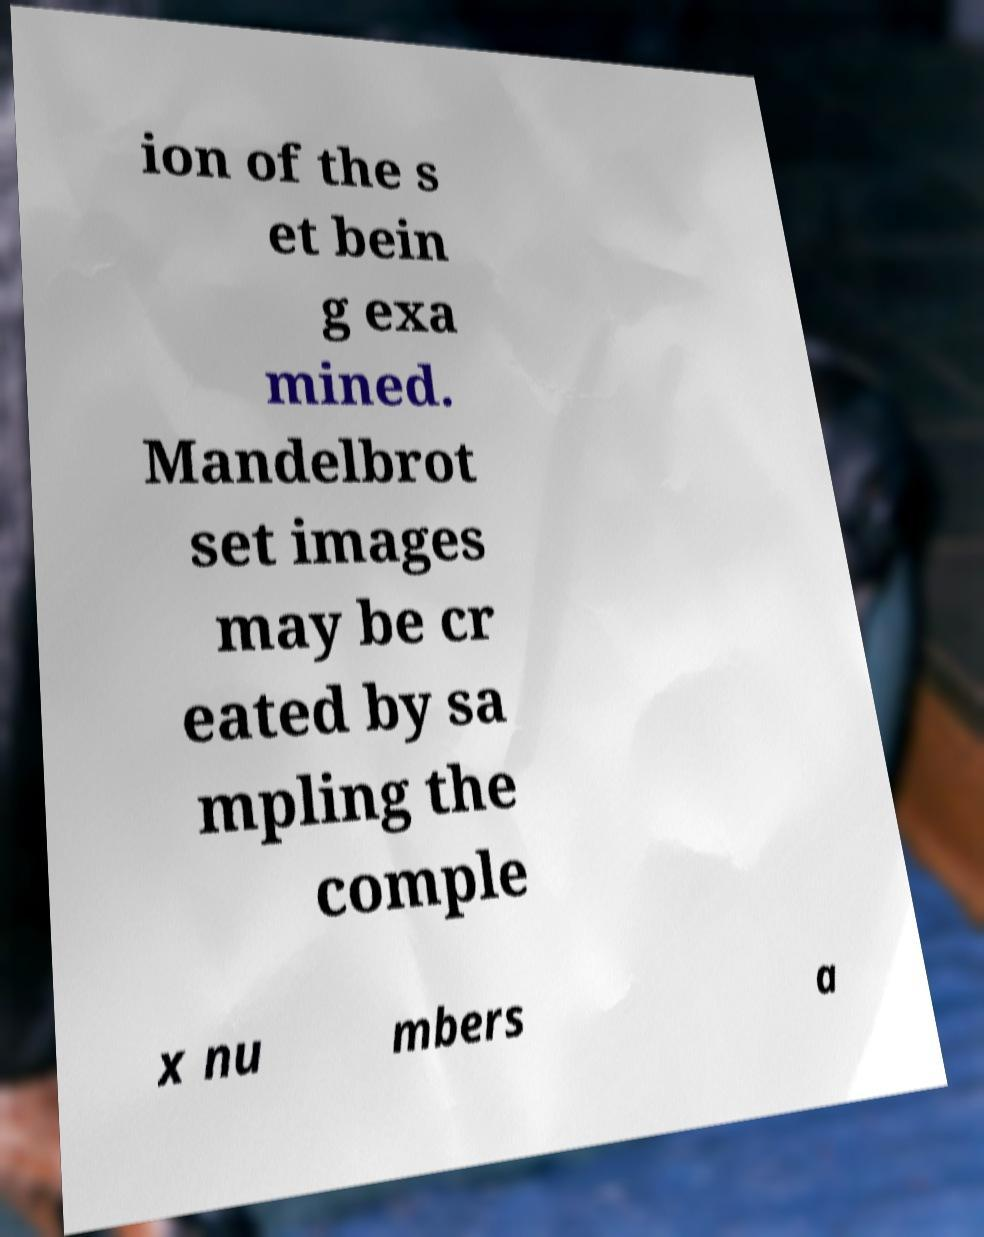Please read and relay the text visible in this image. What does it say? ion of the s et bein g exa mined. Mandelbrot set images may be cr eated by sa mpling the comple x nu mbers a 